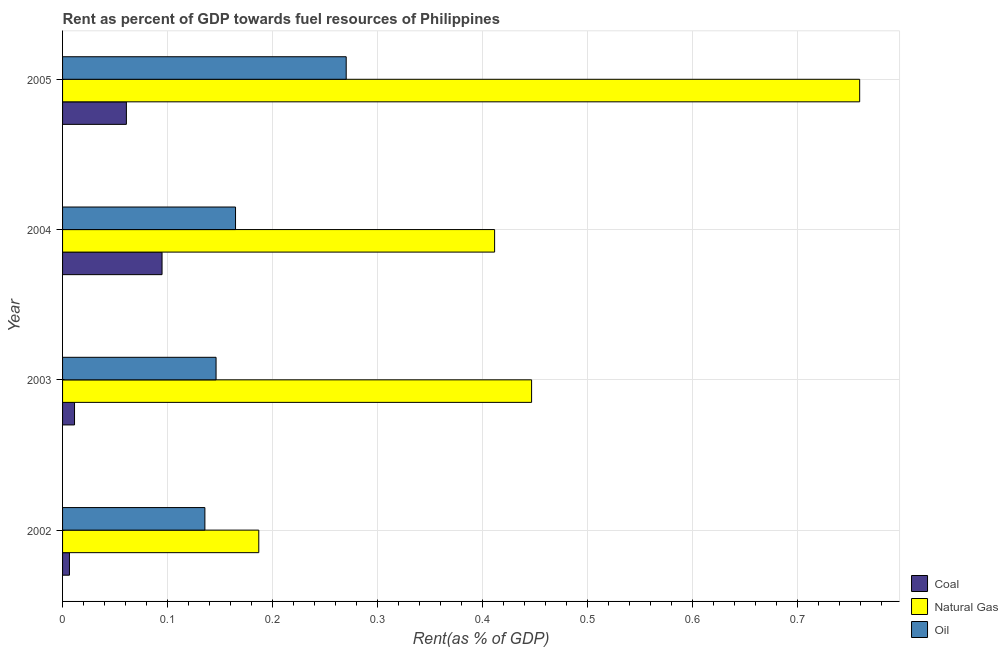How many groups of bars are there?
Your response must be concise. 4. Are the number of bars on each tick of the Y-axis equal?
Provide a succinct answer. Yes. How many bars are there on the 1st tick from the bottom?
Your answer should be very brief. 3. In how many cases, is the number of bars for a given year not equal to the number of legend labels?
Your answer should be compact. 0. What is the rent towards coal in 2004?
Provide a short and direct response. 0.09. Across all years, what is the maximum rent towards oil?
Provide a short and direct response. 0.27. Across all years, what is the minimum rent towards natural gas?
Keep it short and to the point. 0.19. What is the total rent towards coal in the graph?
Make the answer very short. 0.17. What is the difference between the rent towards natural gas in 2002 and that in 2005?
Provide a short and direct response. -0.57. What is the difference between the rent towards natural gas in 2002 and the rent towards coal in 2003?
Your answer should be compact. 0.18. What is the average rent towards coal per year?
Your answer should be compact. 0.04. In the year 2005, what is the difference between the rent towards natural gas and rent towards coal?
Give a very brief answer. 0.7. In how many years, is the rent towards oil greater than 0.1 %?
Keep it short and to the point. 4. What is the ratio of the rent towards oil in 2003 to that in 2004?
Give a very brief answer. 0.89. Is the rent towards oil in 2003 less than that in 2004?
Provide a succinct answer. Yes. Is the difference between the rent towards oil in 2003 and 2004 greater than the difference between the rent towards coal in 2003 and 2004?
Keep it short and to the point. Yes. What is the difference between the highest and the second highest rent towards natural gas?
Give a very brief answer. 0.31. What is the difference between the highest and the lowest rent towards coal?
Give a very brief answer. 0.09. Is the sum of the rent towards natural gas in 2003 and 2005 greater than the maximum rent towards oil across all years?
Offer a terse response. Yes. What does the 2nd bar from the top in 2005 represents?
Your response must be concise. Natural Gas. What does the 1st bar from the bottom in 2004 represents?
Give a very brief answer. Coal. Are all the bars in the graph horizontal?
Give a very brief answer. Yes. How many years are there in the graph?
Your response must be concise. 4. What is the difference between two consecutive major ticks on the X-axis?
Your answer should be very brief. 0.1. Are the values on the major ticks of X-axis written in scientific E-notation?
Your answer should be very brief. No. Does the graph contain any zero values?
Provide a succinct answer. No. How are the legend labels stacked?
Give a very brief answer. Vertical. What is the title of the graph?
Your answer should be compact. Rent as percent of GDP towards fuel resources of Philippines. What is the label or title of the X-axis?
Your answer should be very brief. Rent(as % of GDP). What is the Rent(as % of GDP) in Coal in 2002?
Ensure brevity in your answer.  0.01. What is the Rent(as % of GDP) in Natural Gas in 2002?
Offer a terse response. 0.19. What is the Rent(as % of GDP) in Oil in 2002?
Your answer should be very brief. 0.14. What is the Rent(as % of GDP) of Coal in 2003?
Give a very brief answer. 0.01. What is the Rent(as % of GDP) in Natural Gas in 2003?
Your answer should be very brief. 0.45. What is the Rent(as % of GDP) of Oil in 2003?
Your answer should be very brief. 0.15. What is the Rent(as % of GDP) in Coal in 2004?
Your response must be concise. 0.09. What is the Rent(as % of GDP) in Natural Gas in 2004?
Provide a succinct answer. 0.41. What is the Rent(as % of GDP) of Oil in 2004?
Give a very brief answer. 0.16. What is the Rent(as % of GDP) in Coal in 2005?
Make the answer very short. 0.06. What is the Rent(as % of GDP) of Natural Gas in 2005?
Your answer should be very brief. 0.76. What is the Rent(as % of GDP) in Oil in 2005?
Ensure brevity in your answer.  0.27. Across all years, what is the maximum Rent(as % of GDP) of Coal?
Your response must be concise. 0.09. Across all years, what is the maximum Rent(as % of GDP) in Natural Gas?
Offer a terse response. 0.76. Across all years, what is the maximum Rent(as % of GDP) in Oil?
Make the answer very short. 0.27. Across all years, what is the minimum Rent(as % of GDP) in Coal?
Your answer should be compact. 0.01. Across all years, what is the minimum Rent(as % of GDP) in Natural Gas?
Your answer should be compact. 0.19. Across all years, what is the minimum Rent(as % of GDP) in Oil?
Give a very brief answer. 0.14. What is the total Rent(as % of GDP) in Coal in the graph?
Make the answer very short. 0.17. What is the total Rent(as % of GDP) in Natural Gas in the graph?
Offer a very short reply. 1.8. What is the total Rent(as % of GDP) in Oil in the graph?
Ensure brevity in your answer.  0.72. What is the difference between the Rent(as % of GDP) in Coal in 2002 and that in 2003?
Your answer should be compact. -0. What is the difference between the Rent(as % of GDP) of Natural Gas in 2002 and that in 2003?
Your answer should be compact. -0.26. What is the difference between the Rent(as % of GDP) in Oil in 2002 and that in 2003?
Offer a terse response. -0.01. What is the difference between the Rent(as % of GDP) of Coal in 2002 and that in 2004?
Give a very brief answer. -0.09. What is the difference between the Rent(as % of GDP) in Natural Gas in 2002 and that in 2004?
Provide a succinct answer. -0.22. What is the difference between the Rent(as % of GDP) in Oil in 2002 and that in 2004?
Give a very brief answer. -0.03. What is the difference between the Rent(as % of GDP) of Coal in 2002 and that in 2005?
Ensure brevity in your answer.  -0.05. What is the difference between the Rent(as % of GDP) in Natural Gas in 2002 and that in 2005?
Offer a very short reply. -0.57. What is the difference between the Rent(as % of GDP) in Oil in 2002 and that in 2005?
Your answer should be compact. -0.13. What is the difference between the Rent(as % of GDP) in Coal in 2003 and that in 2004?
Give a very brief answer. -0.08. What is the difference between the Rent(as % of GDP) of Natural Gas in 2003 and that in 2004?
Make the answer very short. 0.04. What is the difference between the Rent(as % of GDP) of Oil in 2003 and that in 2004?
Your answer should be very brief. -0.02. What is the difference between the Rent(as % of GDP) in Coal in 2003 and that in 2005?
Provide a short and direct response. -0.05. What is the difference between the Rent(as % of GDP) of Natural Gas in 2003 and that in 2005?
Provide a succinct answer. -0.31. What is the difference between the Rent(as % of GDP) of Oil in 2003 and that in 2005?
Keep it short and to the point. -0.12. What is the difference between the Rent(as % of GDP) of Coal in 2004 and that in 2005?
Your answer should be compact. 0.03. What is the difference between the Rent(as % of GDP) in Natural Gas in 2004 and that in 2005?
Provide a succinct answer. -0.35. What is the difference between the Rent(as % of GDP) of Oil in 2004 and that in 2005?
Your answer should be very brief. -0.11. What is the difference between the Rent(as % of GDP) of Coal in 2002 and the Rent(as % of GDP) of Natural Gas in 2003?
Your answer should be compact. -0.44. What is the difference between the Rent(as % of GDP) in Coal in 2002 and the Rent(as % of GDP) in Oil in 2003?
Offer a terse response. -0.14. What is the difference between the Rent(as % of GDP) in Natural Gas in 2002 and the Rent(as % of GDP) in Oil in 2003?
Your answer should be very brief. 0.04. What is the difference between the Rent(as % of GDP) of Coal in 2002 and the Rent(as % of GDP) of Natural Gas in 2004?
Ensure brevity in your answer.  -0.4. What is the difference between the Rent(as % of GDP) of Coal in 2002 and the Rent(as % of GDP) of Oil in 2004?
Your answer should be very brief. -0.16. What is the difference between the Rent(as % of GDP) of Natural Gas in 2002 and the Rent(as % of GDP) of Oil in 2004?
Offer a terse response. 0.02. What is the difference between the Rent(as % of GDP) in Coal in 2002 and the Rent(as % of GDP) in Natural Gas in 2005?
Provide a succinct answer. -0.75. What is the difference between the Rent(as % of GDP) of Coal in 2002 and the Rent(as % of GDP) of Oil in 2005?
Offer a very short reply. -0.26. What is the difference between the Rent(as % of GDP) in Natural Gas in 2002 and the Rent(as % of GDP) in Oil in 2005?
Your response must be concise. -0.08. What is the difference between the Rent(as % of GDP) in Coal in 2003 and the Rent(as % of GDP) in Natural Gas in 2004?
Provide a short and direct response. -0.4. What is the difference between the Rent(as % of GDP) in Coal in 2003 and the Rent(as % of GDP) in Oil in 2004?
Make the answer very short. -0.15. What is the difference between the Rent(as % of GDP) of Natural Gas in 2003 and the Rent(as % of GDP) of Oil in 2004?
Make the answer very short. 0.28. What is the difference between the Rent(as % of GDP) in Coal in 2003 and the Rent(as % of GDP) in Natural Gas in 2005?
Give a very brief answer. -0.75. What is the difference between the Rent(as % of GDP) of Coal in 2003 and the Rent(as % of GDP) of Oil in 2005?
Your answer should be very brief. -0.26. What is the difference between the Rent(as % of GDP) of Natural Gas in 2003 and the Rent(as % of GDP) of Oil in 2005?
Provide a short and direct response. 0.18. What is the difference between the Rent(as % of GDP) of Coal in 2004 and the Rent(as % of GDP) of Natural Gas in 2005?
Make the answer very short. -0.66. What is the difference between the Rent(as % of GDP) of Coal in 2004 and the Rent(as % of GDP) of Oil in 2005?
Your answer should be compact. -0.18. What is the difference between the Rent(as % of GDP) of Natural Gas in 2004 and the Rent(as % of GDP) of Oil in 2005?
Your answer should be very brief. 0.14. What is the average Rent(as % of GDP) in Coal per year?
Your answer should be compact. 0.04. What is the average Rent(as % of GDP) of Natural Gas per year?
Keep it short and to the point. 0.45. What is the average Rent(as % of GDP) of Oil per year?
Your answer should be very brief. 0.18. In the year 2002, what is the difference between the Rent(as % of GDP) of Coal and Rent(as % of GDP) of Natural Gas?
Your answer should be compact. -0.18. In the year 2002, what is the difference between the Rent(as % of GDP) in Coal and Rent(as % of GDP) in Oil?
Your answer should be very brief. -0.13. In the year 2002, what is the difference between the Rent(as % of GDP) in Natural Gas and Rent(as % of GDP) in Oil?
Your answer should be compact. 0.05. In the year 2003, what is the difference between the Rent(as % of GDP) in Coal and Rent(as % of GDP) in Natural Gas?
Offer a very short reply. -0.44. In the year 2003, what is the difference between the Rent(as % of GDP) of Coal and Rent(as % of GDP) of Oil?
Provide a succinct answer. -0.13. In the year 2003, what is the difference between the Rent(as % of GDP) in Natural Gas and Rent(as % of GDP) in Oil?
Your answer should be very brief. 0.3. In the year 2004, what is the difference between the Rent(as % of GDP) of Coal and Rent(as % of GDP) of Natural Gas?
Make the answer very short. -0.32. In the year 2004, what is the difference between the Rent(as % of GDP) in Coal and Rent(as % of GDP) in Oil?
Provide a succinct answer. -0.07. In the year 2004, what is the difference between the Rent(as % of GDP) of Natural Gas and Rent(as % of GDP) of Oil?
Ensure brevity in your answer.  0.25. In the year 2005, what is the difference between the Rent(as % of GDP) in Coal and Rent(as % of GDP) in Natural Gas?
Provide a short and direct response. -0.7. In the year 2005, what is the difference between the Rent(as % of GDP) of Coal and Rent(as % of GDP) of Oil?
Provide a short and direct response. -0.21. In the year 2005, what is the difference between the Rent(as % of GDP) in Natural Gas and Rent(as % of GDP) in Oil?
Offer a terse response. 0.49. What is the ratio of the Rent(as % of GDP) of Coal in 2002 to that in 2003?
Ensure brevity in your answer.  0.58. What is the ratio of the Rent(as % of GDP) of Natural Gas in 2002 to that in 2003?
Your answer should be very brief. 0.42. What is the ratio of the Rent(as % of GDP) of Oil in 2002 to that in 2003?
Your answer should be very brief. 0.93. What is the ratio of the Rent(as % of GDP) in Coal in 2002 to that in 2004?
Your answer should be very brief. 0.07. What is the ratio of the Rent(as % of GDP) in Natural Gas in 2002 to that in 2004?
Your response must be concise. 0.45. What is the ratio of the Rent(as % of GDP) in Oil in 2002 to that in 2004?
Provide a succinct answer. 0.82. What is the ratio of the Rent(as % of GDP) of Coal in 2002 to that in 2005?
Your response must be concise. 0.11. What is the ratio of the Rent(as % of GDP) of Natural Gas in 2002 to that in 2005?
Offer a terse response. 0.25. What is the ratio of the Rent(as % of GDP) in Oil in 2002 to that in 2005?
Provide a short and direct response. 0.5. What is the ratio of the Rent(as % of GDP) of Coal in 2003 to that in 2004?
Your answer should be very brief. 0.12. What is the ratio of the Rent(as % of GDP) in Natural Gas in 2003 to that in 2004?
Keep it short and to the point. 1.09. What is the ratio of the Rent(as % of GDP) in Oil in 2003 to that in 2004?
Provide a short and direct response. 0.89. What is the ratio of the Rent(as % of GDP) of Coal in 2003 to that in 2005?
Give a very brief answer. 0.19. What is the ratio of the Rent(as % of GDP) of Natural Gas in 2003 to that in 2005?
Give a very brief answer. 0.59. What is the ratio of the Rent(as % of GDP) in Oil in 2003 to that in 2005?
Your answer should be very brief. 0.54. What is the ratio of the Rent(as % of GDP) in Coal in 2004 to that in 2005?
Your answer should be compact. 1.56. What is the ratio of the Rent(as % of GDP) in Natural Gas in 2004 to that in 2005?
Give a very brief answer. 0.54. What is the ratio of the Rent(as % of GDP) of Oil in 2004 to that in 2005?
Give a very brief answer. 0.61. What is the difference between the highest and the second highest Rent(as % of GDP) of Coal?
Your answer should be compact. 0.03. What is the difference between the highest and the second highest Rent(as % of GDP) of Natural Gas?
Give a very brief answer. 0.31. What is the difference between the highest and the second highest Rent(as % of GDP) in Oil?
Your response must be concise. 0.11. What is the difference between the highest and the lowest Rent(as % of GDP) in Coal?
Ensure brevity in your answer.  0.09. What is the difference between the highest and the lowest Rent(as % of GDP) of Natural Gas?
Give a very brief answer. 0.57. What is the difference between the highest and the lowest Rent(as % of GDP) of Oil?
Offer a very short reply. 0.13. 